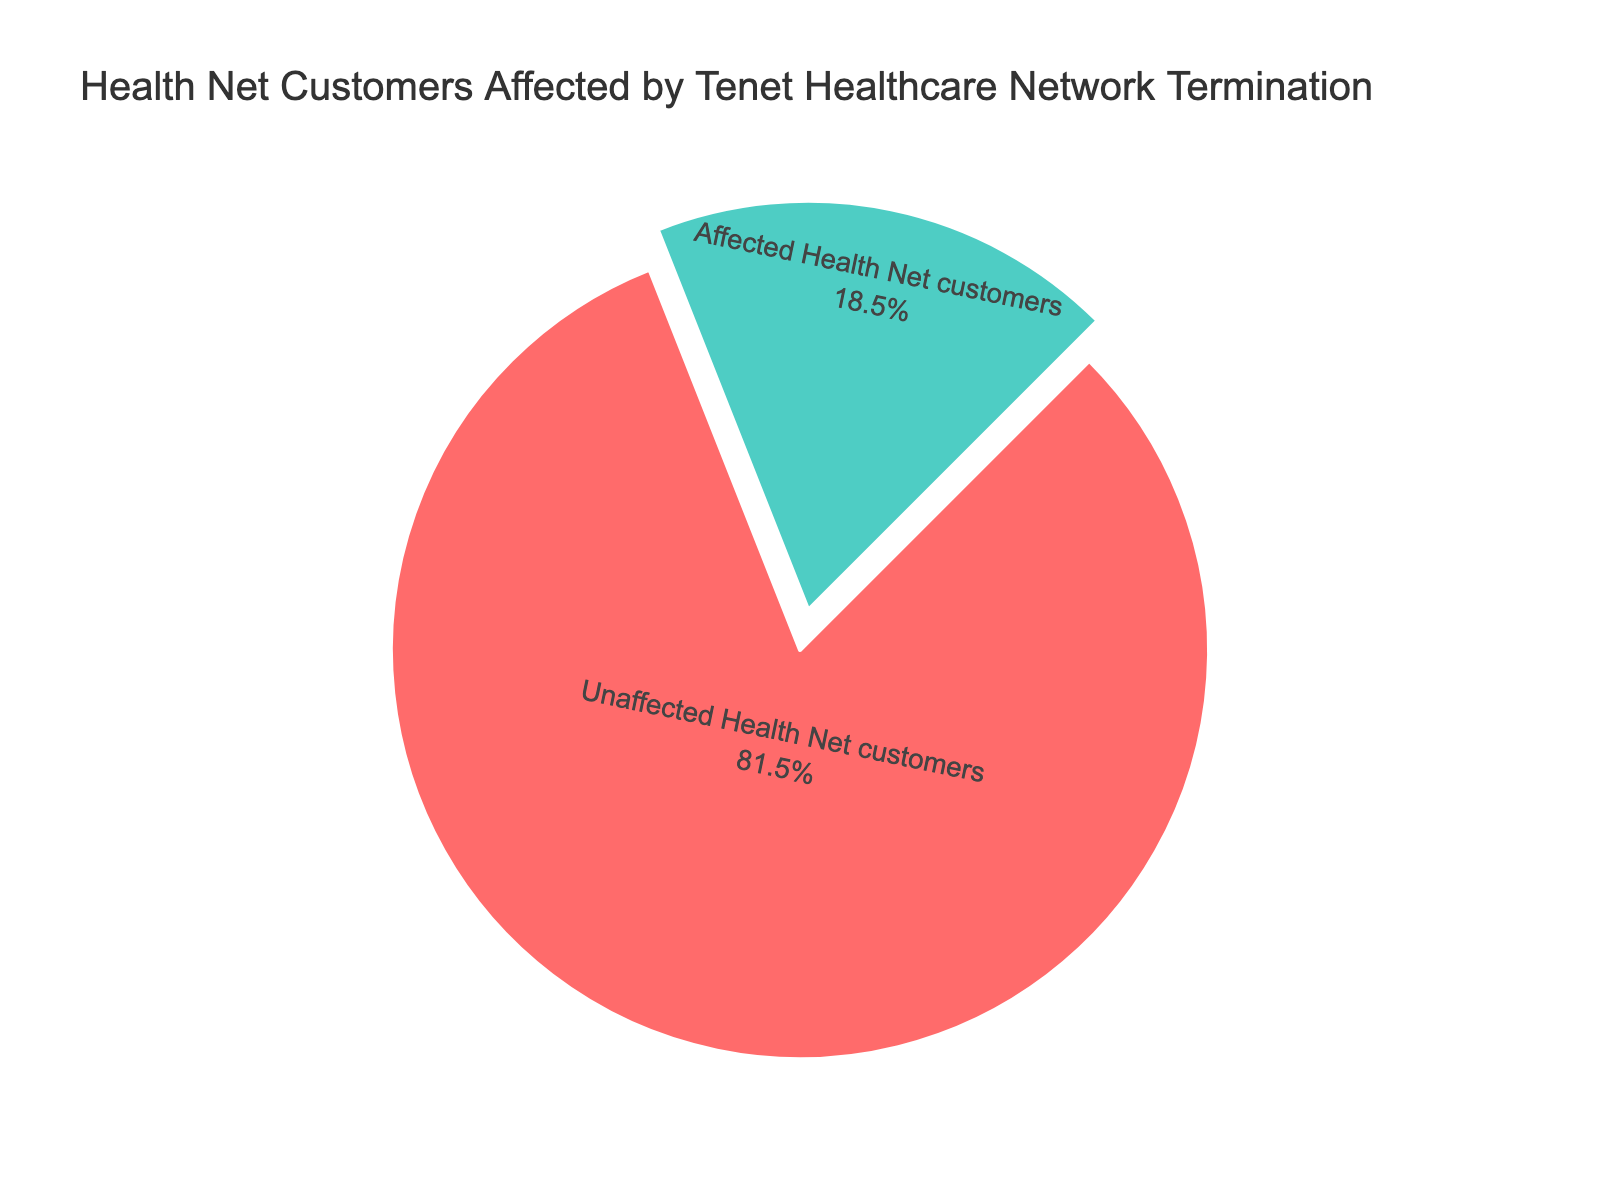What percentage of Health Net customers are affected by Tenet Healthcare network termination? We can directly observe from the pie chart that 18.5% of Health Net customers were affected by the Tenet Healthcare network termination.
Answer: 18.5% What percentage of Health Net customers remain unaffected by the Tenet Healthcare network termination? The pie chart clearly shows that 81.5% of Health Net customers remain unaffected by the termination.
Answer: 81.5% Which group is larger, affected Health Net customers or unaffected Health Net customers? By comparing the percentages in the pie chart, we see that unaffected Health Net customers account for 81.5%, whereas affected Health Net customers account for 18.5%. Hence, unaffected Health Net customers are the larger group.
Answer: Unaffected Health Net customers By what percentage do unaffected Health Net customers exceed affected Health Net customers? By subtracting the affected percentage from the unaffected percentage: 81.5% - 18.5%, we get the difference between the two categories.
Answer: 63% What proportion of the pie chart represents affected Health Net customers? Looking at the visual attribute, the segment representing affected Health Net customers is substantially smaller than the one for unaffected customers. The affected segment constitutes 18.5% of the total pie.
Answer: 18.5% If the total number of Health Net customers is 1,000,000, how many are affected by Tenet Healthcare network termination? To find the number of affected customers, multiply the total number of customers by the affected percentage: 1,000,000 * 0.185.
Answer: 185,000 What is the sum of affected and unaffected Health Net customers percentages? By adding the percentage of affected Health Net customers (18.5%) and the percentage of unaffected Health Net customers (81.5%), we get the total percentage.
Answer: 100% What color represents the unaffected Health Net customers in the pie chart? Observing the visual attributes, the segment for unaffected Health Net customers is colored green.
Answer: Green What category is highlighted or pulled out in the pie chart? From the visual cues, the segment representing affected Health Net customers is pulled out from the pie chart.
Answer: Affected Health Net customers 